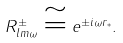Convert formula to latex. <formula><loc_0><loc_0><loc_500><loc_500>R _ { l m \omega } ^ { \pm } \cong e ^ { \pm i \omega r _ { * } } .</formula> 